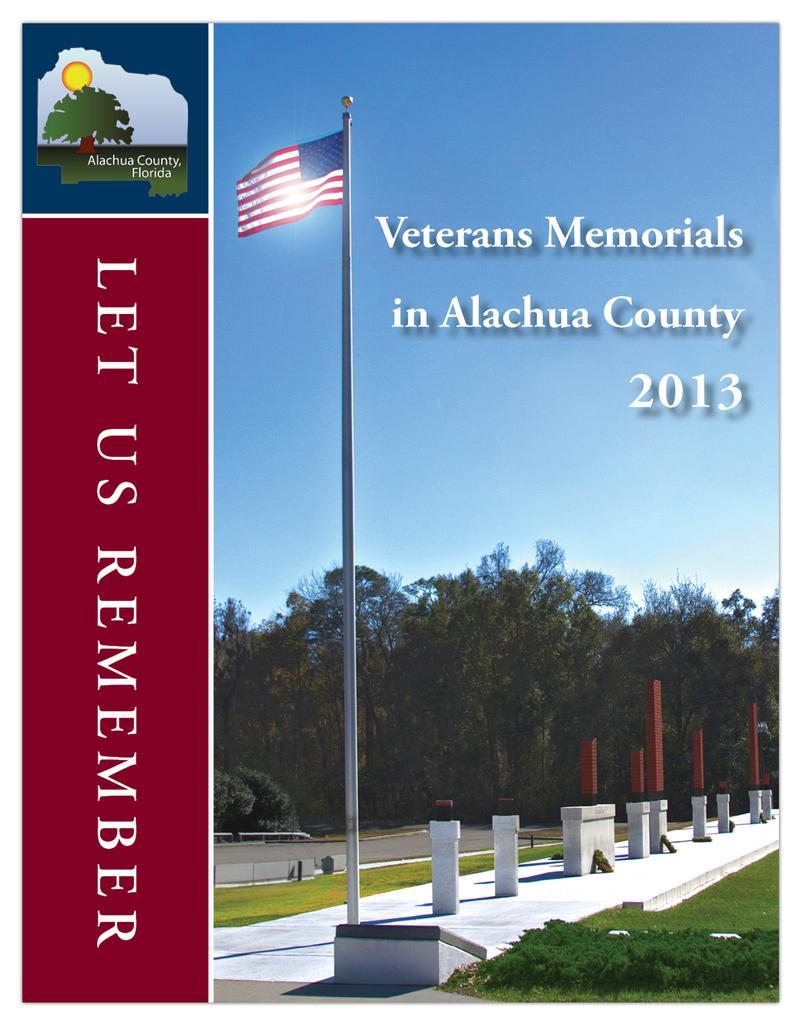In one or two sentences, can you explain what this image depicts? In this image we can see a hoarding, pole, flag, grass, plants, and objects. In the background there are trees and sky. Here we can see something is written on the image. 